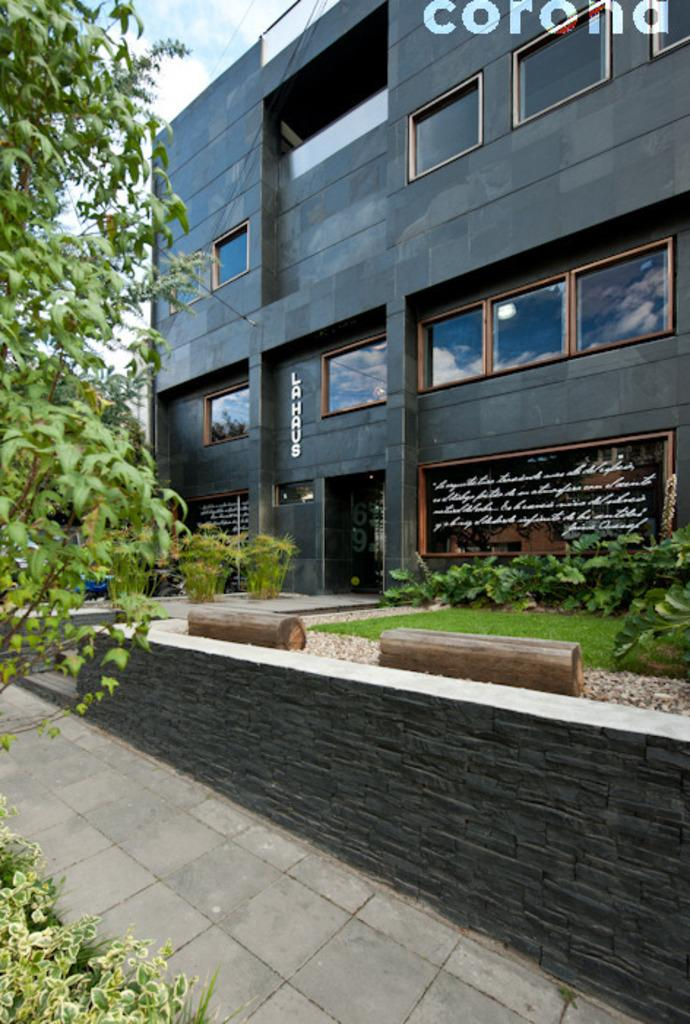What type of surface is visible in the image? There is a pavement in the image. What can be seen in the background of the image? A: There is a building and plants in the background of the image. What type of vegetation is on the left side of the image? There are trees on the left side of the image. What type of hat is the tree wearing on the left side of the image? There are no hats present in the image, as trees do not wear hats. 